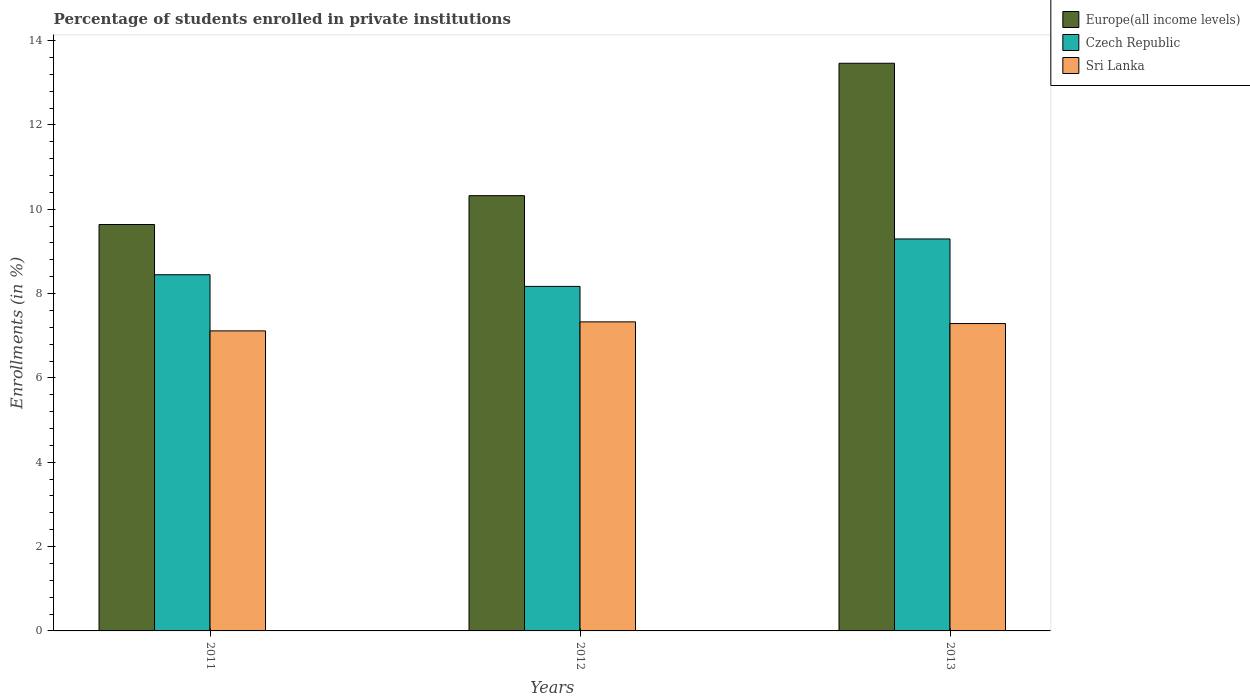Are the number of bars on each tick of the X-axis equal?
Offer a very short reply. Yes. How many bars are there on the 1st tick from the left?
Make the answer very short. 3. In how many cases, is the number of bars for a given year not equal to the number of legend labels?
Offer a very short reply. 0. What is the percentage of trained teachers in Czech Republic in 2011?
Give a very brief answer. 8.45. Across all years, what is the maximum percentage of trained teachers in Sri Lanka?
Keep it short and to the point. 7.33. Across all years, what is the minimum percentage of trained teachers in Europe(all income levels)?
Your answer should be compact. 9.64. In which year was the percentage of trained teachers in Czech Republic minimum?
Give a very brief answer. 2012. What is the total percentage of trained teachers in Czech Republic in the graph?
Your response must be concise. 25.91. What is the difference between the percentage of trained teachers in Sri Lanka in 2011 and that in 2012?
Keep it short and to the point. -0.21. What is the difference between the percentage of trained teachers in Sri Lanka in 2011 and the percentage of trained teachers in Europe(all income levels) in 2012?
Your answer should be compact. -3.21. What is the average percentage of trained teachers in Europe(all income levels) per year?
Offer a very short reply. 11.14. In the year 2011, what is the difference between the percentage of trained teachers in Europe(all income levels) and percentage of trained teachers in Sri Lanka?
Offer a very short reply. 2.52. In how many years, is the percentage of trained teachers in Sri Lanka greater than 10.8 %?
Provide a short and direct response. 0. What is the ratio of the percentage of trained teachers in Czech Republic in 2012 to that in 2013?
Make the answer very short. 0.88. Is the percentage of trained teachers in Sri Lanka in 2011 less than that in 2013?
Make the answer very short. Yes. What is the difference between the highest and the second highest percentage of trained teachers in Czech Republic?
Keep it short and to the point. 0.85. What is the difference between the highest and the lowest percentage of trained teachers in Sri Lanka?
Provide a succinct answer. 0.21. In how many years, is the percentage of trained teachers in Europe(all income levels) greater than the average percentage of trained teachers in Europe(all income levels) taken over all years?
Ensure brevity in your answer.  1. Is the sum of the percentage of trained teachers in Czech Republic in 2011 and 2013 greater than the maximum percentage of trained teachers in Sri Lanka across all years?
Your response must be concise. Yes. What does the 1st bar from the left in 2011 represents?
Your response must be concise. Europe(all income levels). What does the 2nd bar from the right in 2013 represents?
Offer a very short reply. Czech Republic. Is it the case that in every year, the sum of the percentage of trained teachers in Sri Lanka and percentage of trained teachers in Czech Republic is greater than the percentage of trained teachers in Europe(all income levels)?
Your response must be concise. Yes. How many bars are there?
Your answer should be compact. 9. How many years are there in the graph?
Ensure brevity in your answer.  3. What is the difference between two consecutive major ticks on the Y-axis?
Give a very brief answer. 2. Does the graph contain grids?
Keep it short and to the point. No. Where does the legend appear in the graph?
Your response must be concise. Top right. How many legend labels are there?
Ensure brevity in your answer.  3. How are the legend labels stacked?
Your answer should be very brief. Vertical. What is the title of the graph?
Keep it short and to the point. Percentage of students enrolled in private institutions. What is the label or title of the X-axis?
Offer a very short reply. Years. What is the label or title of the Y-axis?
Offer a very short reply. Enrollments (in %). What is the Enrollments (in %) of Europe(all income levels) in 2011?
Give a very brief answer. 9.64. What is the Enrollments (in %) of Czech Republic in 2011?
Keep it short and to the point. 8.45. What is the Enrollments (in %) in Sri Lanka in 2011?
Ensure brevity in your answer.  7.12. What is the Enrollments (in %) of Europe(all income levels) in 2012?
Ensure brevity in your answer.  10.32. What is the Enrollments (in %) in Czech Republic in 2012?
Provide a succinct answer. 8.17. What is the Enrollments (in %) of Sri Lanka in 2012?
Offer a terse response. 7.33. What is the Enrollments (in %) of Europe(all income levels) in 2013?
Your answer should be compact. 13.46. What is the Enrollments (in %) in Czech Republic in 2013?
Give a very brief answer. 9.29. What is the Enrollments (in %) of Sri Lanka in 2013?
Make the answer very short. 7.29. Across all years, what is the maximum Enrollments (in %) of Europe(all income levels)?
Your answer should be very brief. 13.46. Across all years, what is the maximum Enrollments (in %) of Czech Republic?
Make the answer very short. 9.29. Across all years, what is the maximum Enrollments (in %) in Sri Lanka?
Provide a succinct answer. 7.33. Across all years, what is the minimum Enrollments (in %) in Europe(all income levels)?
Make the answer very short. 9.64. Across all years, what is the minimum Enrollments (in %) in Czech Republic?
Make the answer very short. 8.17. Across all years, what is the minimum Enrollments (in %) of Sri Lanka?
Provide a short and direct response. 7.12. What is the total Enrollments (in %) of Europe(all income levels) in the graph?
Give a very brief answer. 33.42. What is the total Enrollments (in %) of Czech Republic in the graph?
Provide a succinct answer. 25.91. What is the total Enrollments (in %) in Sri Lanka in the graph?
Offer a very short reply. 21.73. What is the difference between the Enrollments (in %) of Europe(all income levels) in 2011 and that in 2012?
Your answer should be very brief. -0.68. What is the difference between the Enrollments (in %) of Czech Republic in 2011 and that in 2012?
Make the answer very short. 0.28. What is the difference between the Enrollments (in %) of Sri Lanka in 2011 and that in 2012?
Provide a short and direct response. -0.21. What is the difference between the Enrollments (in %) in Europe(all income levels) in 2011 and that in 2013?
Offer a very short reply. -3.82. What is the difference between the Enrollments (in %) in Czech Republic in 2011 and that in 2013?
Offer a terse response. -0.85. What is the difference between the Enrollments (in %) in Sri Lanka in 2011 and that in 2013?
Offer a terse response. -0.17. What is the difference between the Enrollments (in %) in Europe(all income levels) in 2012 and that in 2013?
Offer a terse response. -3.14. What is the difference between the Enrollments (in %) in Czech Republic in 2012 and that in 2013?
Keep it short and to the point. -1.12. What is the difference between the Enrollments (in %) of Sri Lanka in 2012 and that in 2013?
Provide a short and direct response. 0.04. What is the difference between the Enrollments (in %) of Europe(all income levels) in 2011 and the Enrollments (in %) of Czech Republic in 2012?
Provide a short and direct response. 1.47. What is the difference between the Enrollments (in %) in Europe(all income levels) in 2011 and the Enrollments (in %) in Sri Lanka in 2012?
Offer a very short reply. 2.31. What is the difference between the Enrollments (in %) of Czech Republic in 2011 and the Enrollments (in %) of Sri Lanka in 2012?
Keep it short and to the point. 1.12. What is the difference between the Enrollments (in %) of Europe(all income levels) in 2011 and the Enrollments (in %) of Czech Republic in 2013?
Give a very brief answer. 0.34. What is the difference between the Enrollments (in %) of Europe(all income levels) in 2011 and the Enrollments (in %) of Sri Lanka in 2013?
Offer a terse response. 2.35. What is the difference between the Enrollments (in %) in Czech Republic in 2011 and the Enrollments (in %) in Sri Lanka in 2013?
Ensure brevity in your answer.  1.16. What is the difference between the Enrollments (in %) in Europe(all income levels) in 2012 and the Enrollments (in %) in Sri Lanka in 2013?
Your response must be concise. 3.03. What is the difference between the Enrollments (in %) of Czech Republic in 2012 and the Enrollments (in %) of Sri Lanka in 2013?
Give a very brief answer. 0.88. What is the average Enrollments (in %) in Europe(all income levels) per year?
Offer a very short reply. 11.14. What is the average Enrollments (in %) of Czech Republic per year?
Your answer should be compact. 8.64. What is the average Enrollments (in %) in Sri Lanka per year?
Give a very brief answer. 7.24. In the year 2011, what is the difference between the Enrollments (in %) of Europe(all income levels) and Enrollments (in %) of Czech Republic?
Ensure brevity in your answer.  1.19. In the year 2011, what is the difference between the Enrollments (in %) of Europe(all income levels) and Enrollments (in %) of Sri Lanka?
Offer a terse response. 2.52. In the year 2011, what is the difference between the Enrollments (in %) in Czech Republic and Enrollments (in %) in Sri Lanka?
Ensure brevity in your answer.  1.33. In the year 2012, what is the difference between the Enrollments (in %) of Europe(all income levels) and Enrollments (in %) of Czech Republic?
Your response must be concise. 2.15. In the year 2012, what is the difference between the Enrollments (in %) in Europe(all income levels) and Enrollments (in %) in Sri Lanka?
Your answer should be compact. 2.99. In the year 2012, what is the difference between the Enrollments (in %) of Czech Republic and Enrollments (in %) of Sri Lanka?
Your response must be concise. 0.84. In the year 2013, what is the difference between the Enrollments (in %) in Europe(all income levels) and Enrollments (in %) in Czech Republic?
Give a very brief answer. 4.17. In the year 2013, what is the difference between the Enrollments (in %) of Europe(all income levels) and Enrollments (in %) of Sri Lanka?
Your response must be concise. 6.17. In the year 2013, what is the difference between the Enrollments (in %) of Czech Republic and Enrollments (in %) of Sri Lanka?
Keep it short and to the point. 2.01. What is the ratio of the Enrollments (in %) of Europe(all income levels) in 2011 to that in 2012?
Provide a short and direct response. 0.93. What is the ratio of the Enrollments (in %) of Czech Republic in 2011 to that in 2012?
Offer a terse response. 1.03. What is the ratio of the Enrollments (in %) of Sri Lanka in 2011 to that in 2012?
Give a very brief answer. 0.97. What is the ratio of the Enrollments (in %) of Europe(all income levels) in 2011 to that in 2013?
Ensure brevity in your answer.  0.72. What is the ratio of the Enrollments (in %) of Czech Republic in 2011 to that in 2013?
Give a very brief answer. 0.91. What is the ratio of the Enrollments (in %) of Sri Lanka in 2011 to that in 2013?
Provide a succinct answer. 0.98. What is the ratio of the Enrollments (in %) in Europe(all income levels) in 2012 to that in 2013?
Your answer should be very brief. 0.77. What is the ratio of the Enrollments (in %) in Czech Republic in 2012 to that in 2013?
Provide a short and direct response. 0.88. What is the ratio of the Enrollments (in %) in Sri Lanka in 2012 to that in 2013?
Offer a very short reply. 1.01. What is the difference between the highest and the second highest Enrollments (in %) of Europe(all income levels)?
Provide a short and direct response. 3.14. What is the difference between the highest and the second highest Enrollments (in %) in Czech Republic?
Keep it short and to the point. 0.85. What is the difference between the highest and the second highest Enrollments (in %) in Sri Lanka?
Provide a short and direct response. 0.04. What is the difference between the highest and the lowest Enrollments (in %) of Europe(all income levels)?
Your response must be concise. 3.82. What is the difference between the highest and the lowest Enrollments (in %) of Czech Republic?
Offer a very short reply. 1.12. What is the difference between the highest and the lowest Enrollments (in %) in Sri Lanka?
Offer a terse response. 0.21. 